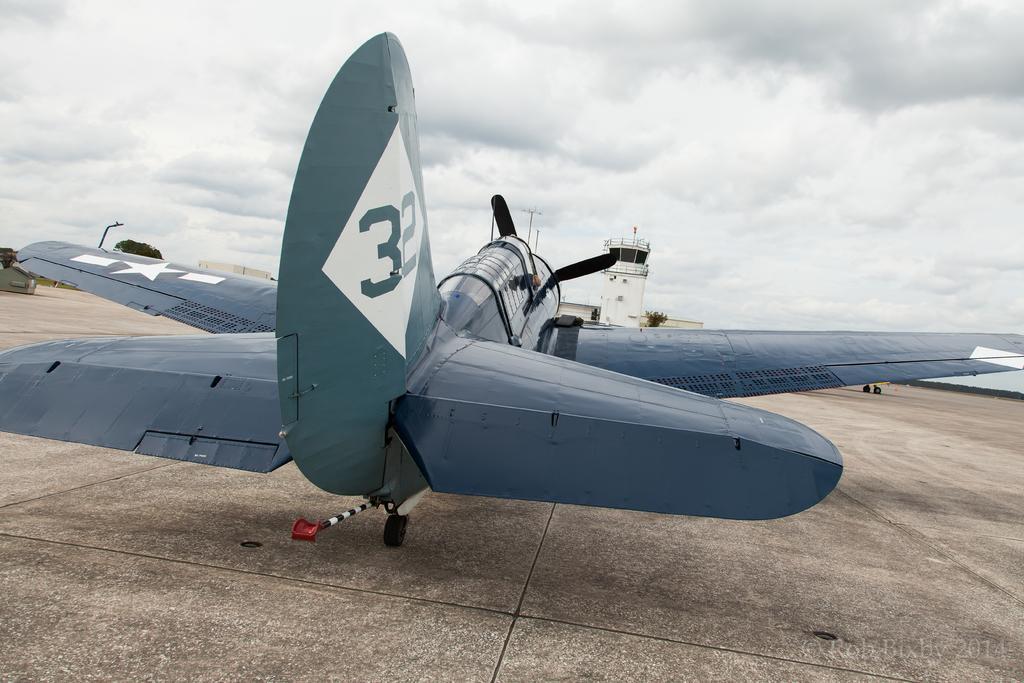In one or two sentences, can you explain what this image depicts? In this picture I can see there is a aircraft, it has wings, wheels and there is a cabin. In the backdrop I can see there is a building, tree and the sky is clear. 